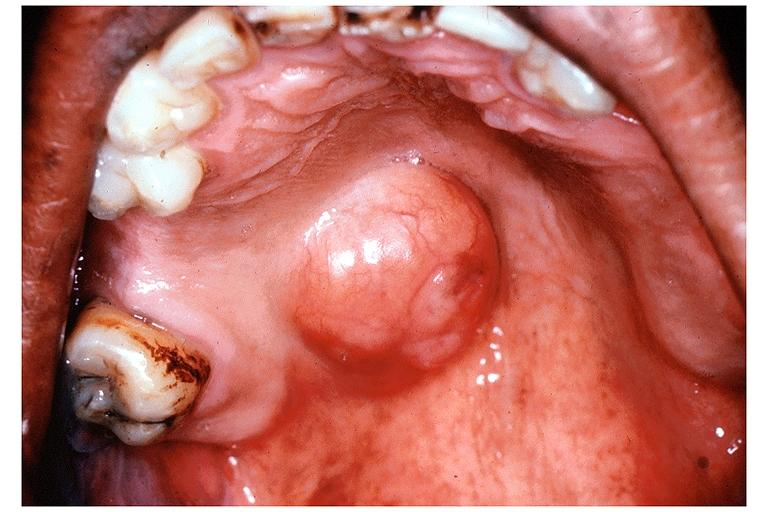what is present?
Answer the question using a single word or phrase. Oral 